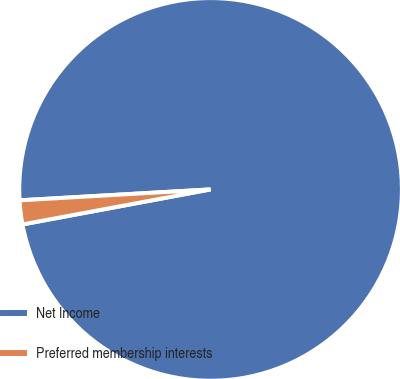Convert chart. <chart><loc_0><loc_0><loc_500><loc_500><pie_chart><fcel>Net Income<fcel>Preferred membership interests<nl><fcel>97.98%<fcel>2.02%<nl></chart> 